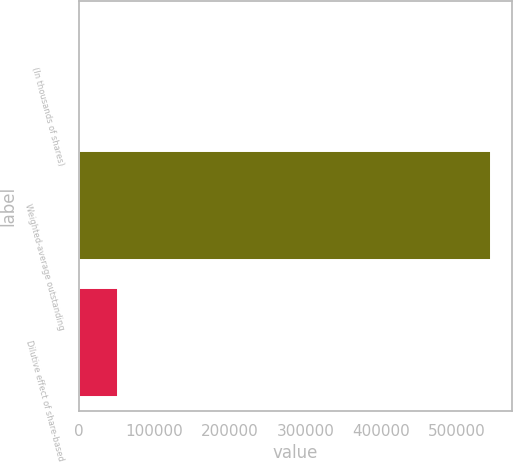<chart> <loc_0><loc_0><loc_500><loc_500><bar_chart><fcel>(In thousands of shares)<fcel>Weighted-average outstanding<fcel>Dilutive effect of share-based<nl><fcel>2006<fcel>545596<fcel>51988.1<nl></chart> 